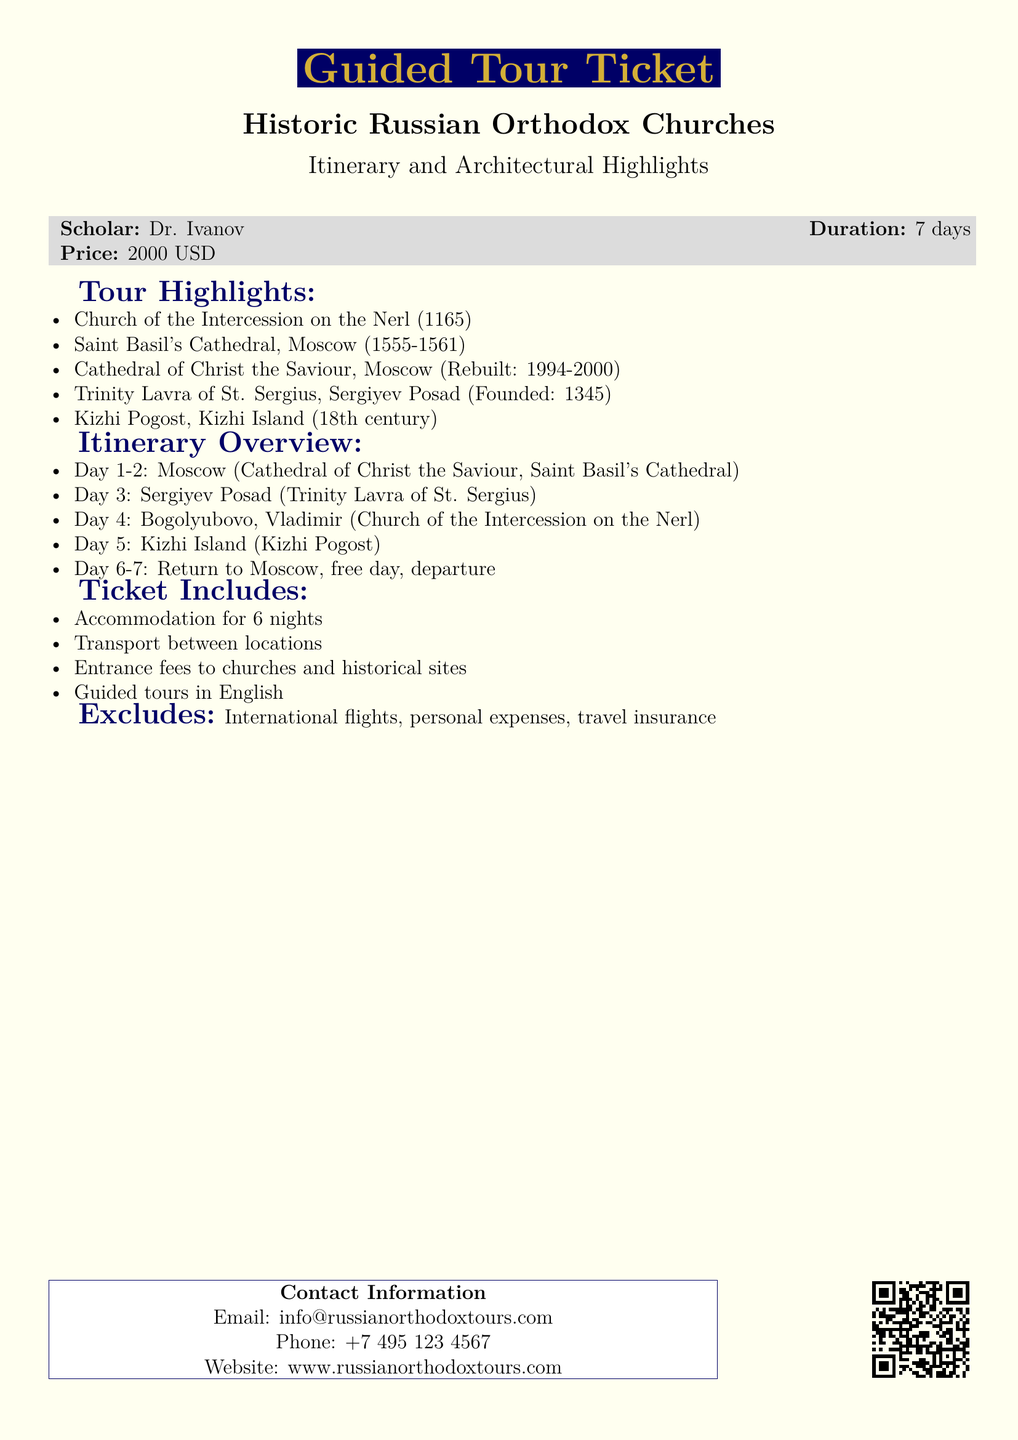What is the duration of the tour? The duration is specified at the beginning of the ticket, indicating it lasts for 7 days.
Answer: 7 days Who is the scholar leading the tour? The document mentions Dr. Ivanov as the scholar guiding this tour.
Answer: Dr. Ivanov What is the price of the ticket? The ticket price is listed in the document, which is 2000 USD.
Answer: 2000 USD Which church was founded in 1345? The document lists the Trinity Lavra of St. Sergius, which has this founding date.
Answer: Trinity Lavra of St. Sergius On which day is the visit to Kizhi Island scheduled? The itinerary specifies that Kizhi Island is visited on Day 5 of the tour.
Answer: Day 5 What are the inclusions of the ticket? The document lists accommodations, transport, entrance fees, and guided tours as included.
Answer: Accommodation for 6 nights, Transport between locations, Entrance fees to churches and historical sites, Guided tours in English What is excluded from the ticket? The document specifies that international flights, personal expenses, and travel insurance are not included.
Answer: International flights, personal expenses, travel insurance Which cathedral was rebuilt between 1994 and 2000? The Cathedral of Christ the Saviour is noted to have been rebuilt in this timeframe.
Answer: Cathedral of Christ the Saviour What is the last activity in the itinerary? The itinerary indicates a free day followed by departure as the last activity.
Answer: Free day, departure 